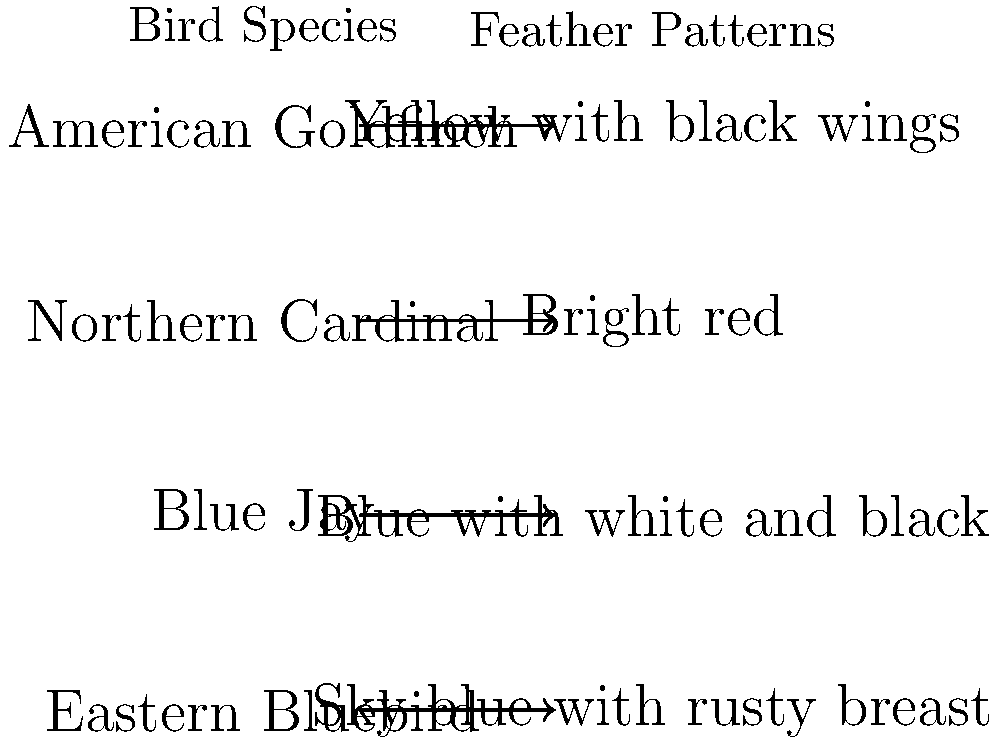Match the bird species to their unique feather patterns by drawing lines between the corresponding pairs. Which bird is known for its "sky blue with rusty breast" plumage? To solve this question, let's analyze each bird species and its corresponding feather pattern:

1. American Goldfinch: Known for its bright yellow body with black wings, which matches the "Yellow with black wings" pattern.

2. Northern Cardinal: Easily recognizable by its "Bright red" plumage, especially in males.

3. Blue Jay: Characterized by its blue upperparts with white underparts and a black necklace, matching the "Blue with white and black" pattern.

4. Eastern Bluebird: Distinguished by its "Sky blue with rusty breast" coloration.

By process of elimination and matching the descriptions, we can conclude that the bird known for its "sky blue with rusty breast" plumage is the Eastern Bluebird.

This question tests your knowledge of bird species and their distinctive feather patterns, which is essential for an aspiring young birder. It also relates to the work of ornithologists like Dara M. Wilson, who study bird behavior and characteristics.
Answer: Eastern Bluebird 